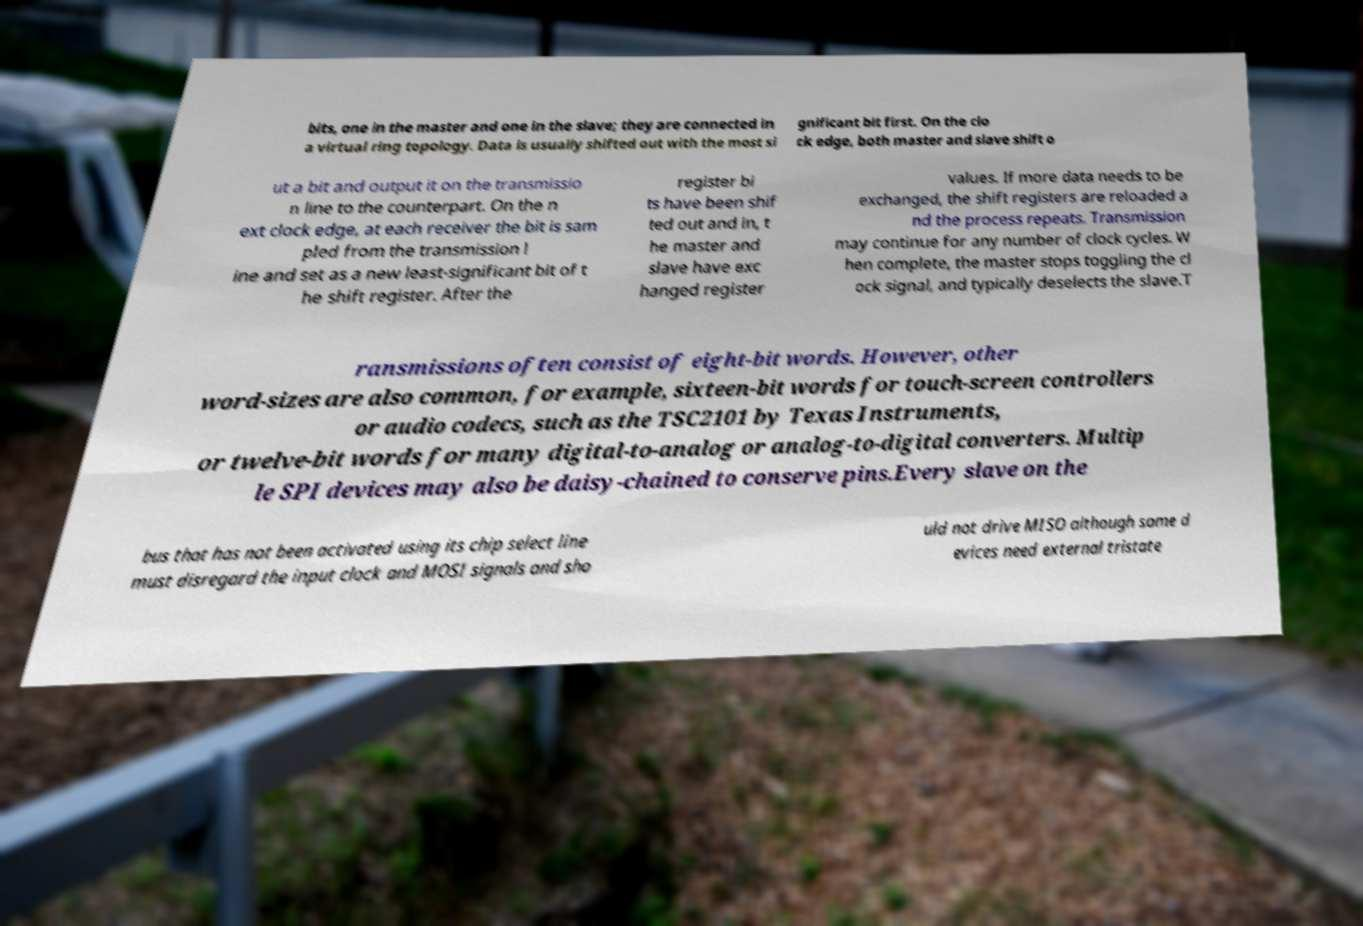Please identify and transcribe the text found in this image. bits, one in the master and one in the slave; they are connected in a virtual ring topology. Data is usually shifted out with the most si gnificant bit first. On the clo ck edge, both master and slave shift o ut a bit and output it on the transmissio n line to the counterpart. On the n ext clock edge, at each receiver the bit is sam pled from the transmission l ine and set as a new least-significant bit of t he shift register. After the register bi ts have been shif ted out and in, t he master and slave have exc hanged register values. If more data needs to be exchanged, the shift registers are reloaded a nd the process repeats. Transmission may continue for any number of clock cycles. W hen complete, the master stops toggling the cl ock signal, and typically deselects the slave.T ransmissions often consist of eight-bit words. However, other word-sizes are also common, for example, sixteen-bit words for touch-screen controllers or audio codecs, such as the TSC2101 by Texas Instruments, or twelve-bit words for many digital-to-analog or analog-to-digital converters. Multip le SPI devices may also be daisy-chained to conserve pins.Every slave on the bus that has not been activated using its chip select line must disregard the input clock and MOSI signals and sho uld not drive MISO although some d evices need external tristate 